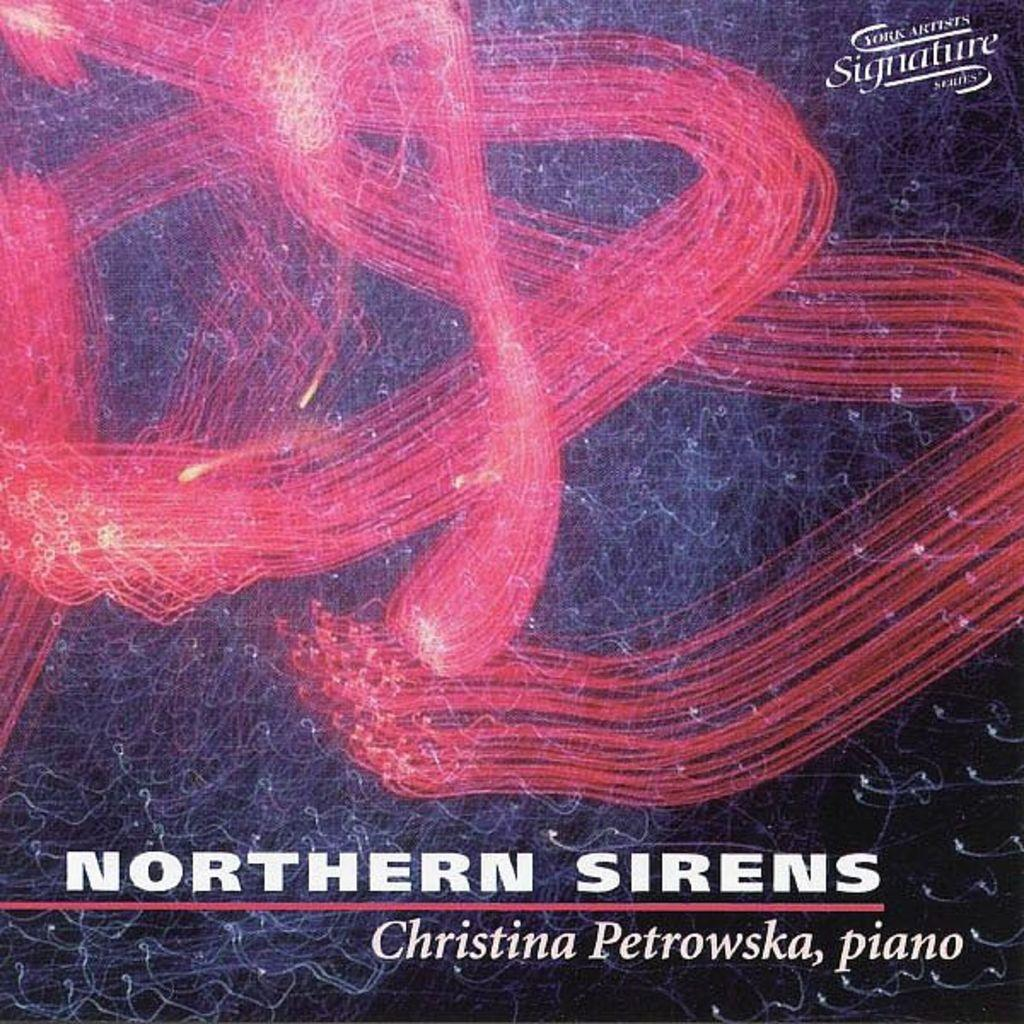<image>
Render a clear and concise summary of the photo. The album cover for Northern Sirens by Christina Petrowska. 